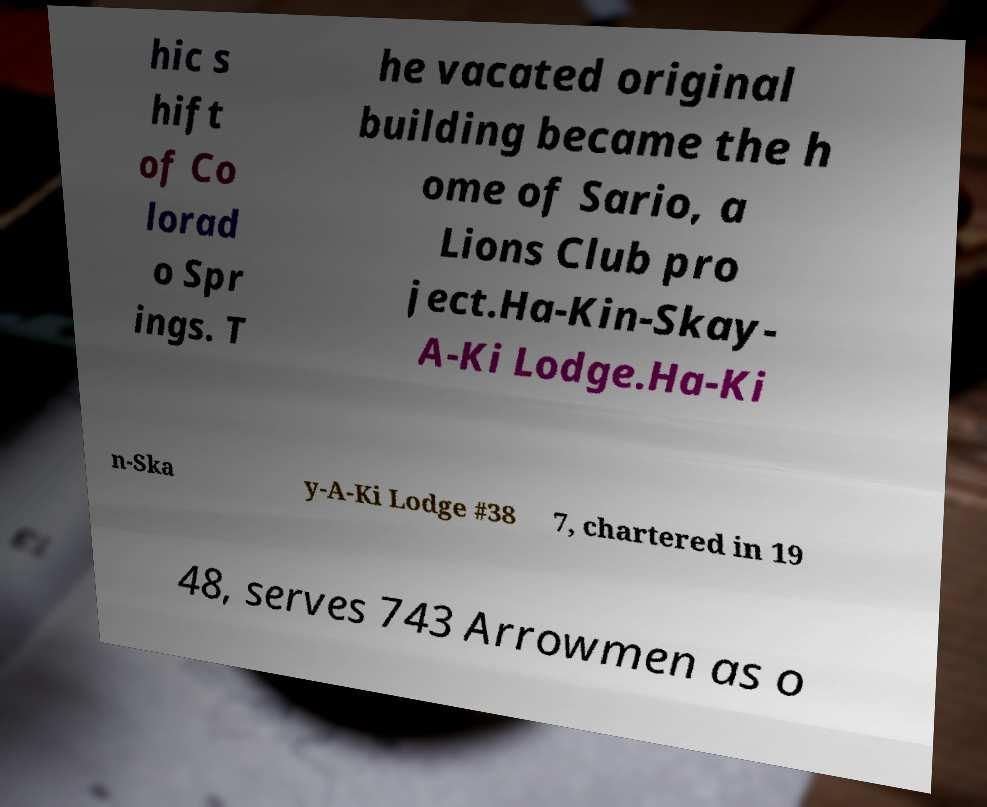For documentation purposes, I need the text within this image transcribed. Could you provide that? hic s hift of Co lorad o Spr ings. T he vacated original building became the h ome of Sario, a Lions Club pro ject.Ha-Kin-Skay- A-Ki Lodge.Ha-Ki n-Ska y-A-Ki Lodge #38 7, chartered in 19 48, serves 743 Arrowmen as o 